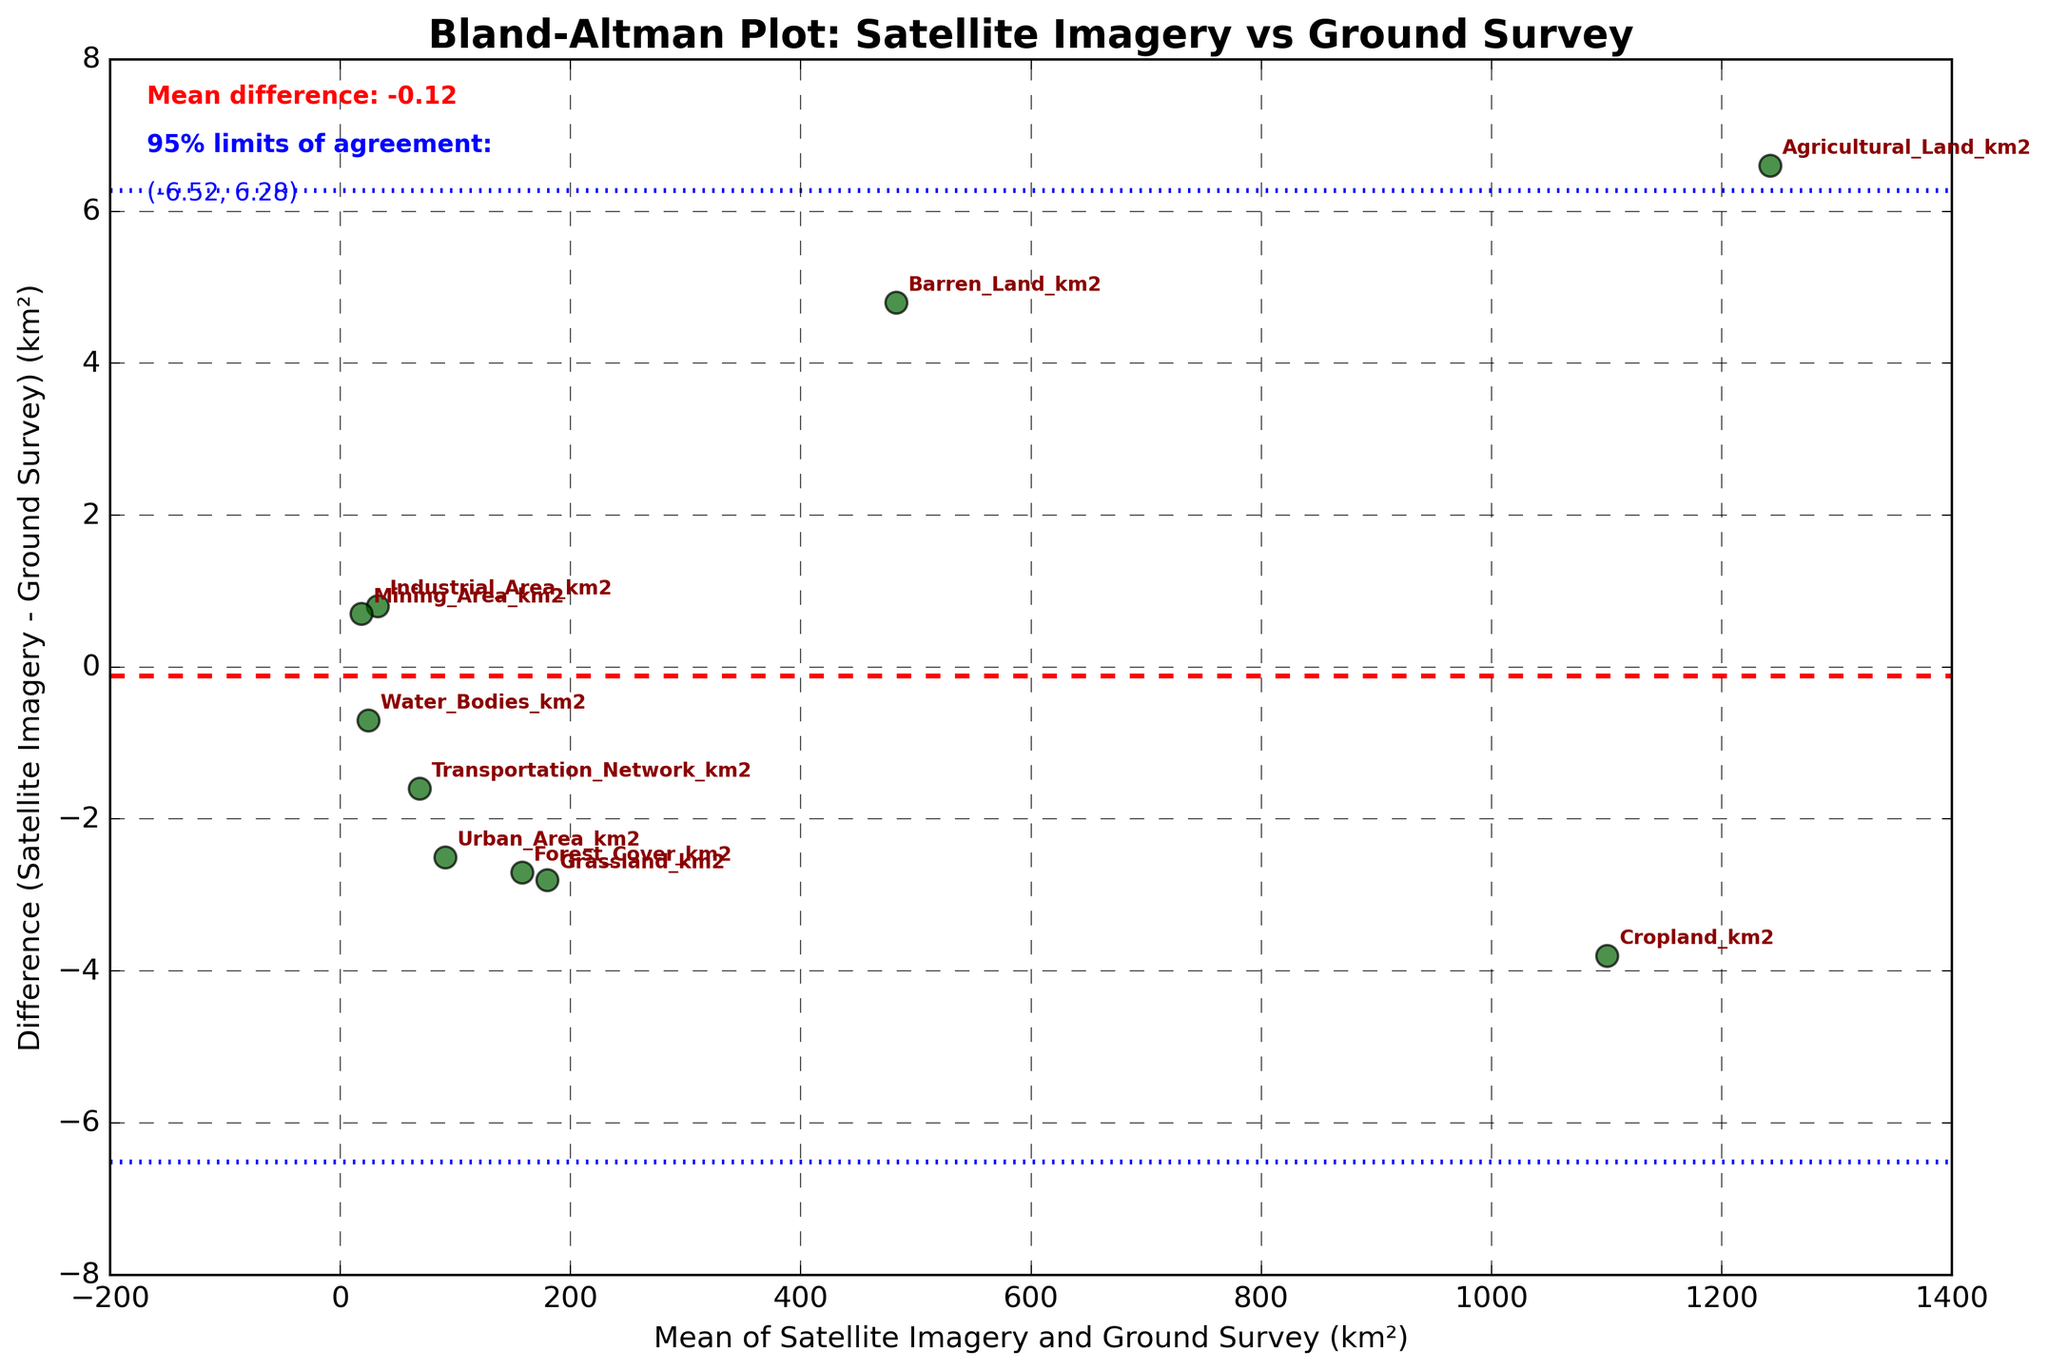what is the title of the plot? The title of the plot is displayed at the top center of the figure. It provides an overview of what the plot represents. In this case, the plot title is "Bland-Altman Plot: Satellite Imagery vs Ground Survey".
Answer: Bland-Altman Plot: Satellite Imagery vs Ground Survey how many different land use categories are indicated in the plot? Each data point on the plot corresponds to a different land use category, which is annotated with text labels. There are 10 land use categories indicated in the plot.
Answer: 10 what do the blue dashed lines represent in the plot? The blue dashed lines represent the 95% limits of agreement which are calculated as the mean difference ± 1.96 times the standard deviation of the differences. These lines indicate the range within which most differences between satellite imagery and ground survey measurements are expected to fall.
Answer: 95% limits of agreement which land use category has the highest measured mean area? The mean area for each land use category is calculated by averaging the satellite imagery and ground survey measurements. The category with the highest mean area is Cropland, which appears farthest to the right on the x-axis.
Answer: Cropland what does the red dashed line indicate on the plot? The red dashed line on the plot represents the mean difference between the satellite imagery and ground survey measurements. It shows whether there is a systematic bias between the two methods.
Answer: mean difference which land use category shows the largest difference in measurements between satellite imagery and ground survey? By observing the distance from the x-axis (mean) to the data point, the land use category "Agricultural Land" shows the largest difference as its data point is the farthest from the x-axis.
Answer: Agricultural Land what is the mean difference between the satellite imagery and ground survey measurements? The mean difference can be found as the red dashed line on the plot. It is also mentioned in the text within the plot: "Mean difference: 0.21".
Answer: 0.21 km² what are the 95% limits of agreement for the measurements? The 95% limits of agreement are indicated by the blue dashed lines and are also textually displayed in the plot as: "( -2.92, 3.34 )". These values are calculated by mean difference ± 1.96 times the standard deviation of the differences.
Answer: -2.92 to 3.34 which land use category's area is most accurately measured by satellite imagery compared to the ground survey? The category with the smallest difference between satellite imagery and ground survey is "Barren Land", as it is closest to the x-axis (mean difference = 0 line) in the plot.
Answer: Barren Land are there any land use categories for which satellite imagery consistently measures higher areas than ground surveys? To determine this, we look for data points above the mean difference (red dashed line). Categories like "Agricultural Land" and "Transportation Network" are above this line, indicating satellite imagery consistently measures higher areas for these categories.
Answer: Agricultural Land, Transportation Network 